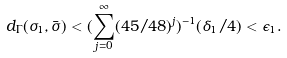<formula> <loc_0><loc_0><loc_500><loc_500>d _ { \Gamma } ( \sigma _ { 1 } , \bar { \sigma } ) < ( \sum _ { j = 0 } ^ { \infty } ( 4 5 / 4 8 ) ^ { j } ) ^ { - 1 } ( \delta _ { 1 } / 4 ) < \epsilon _ { 1 } .</formula> 